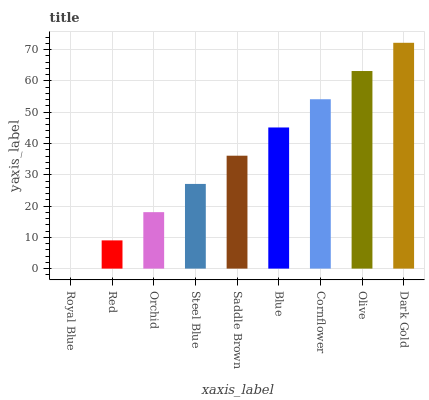Is Royal Blue the minimum?
Answer yes or no. Yes. Is Dark Gold the maximum?
Answer yes or no. Yes. Is Red the minimum?
Answer yes or no. No. Is Red the maximum?
Answer yes or no. No. Is Red greater than Royal Blue?
Answer yes or no. Yes. Is Royal Blue less than Red?
Answer yes or no. Yes. Is Royal Blue greater than Red?
Answer yes or no. No. Is Red less than Royal Blue?
Answer yes or no. No. Is Saddle Brown the high median?
Answer yes or no. Yes. Is Saddle Brown the low median?
Answer yes or no. Yes. Is Red the high median?
Answer yes or no. No. Is Steel Blue the low median?
Answer yes or no. No. 